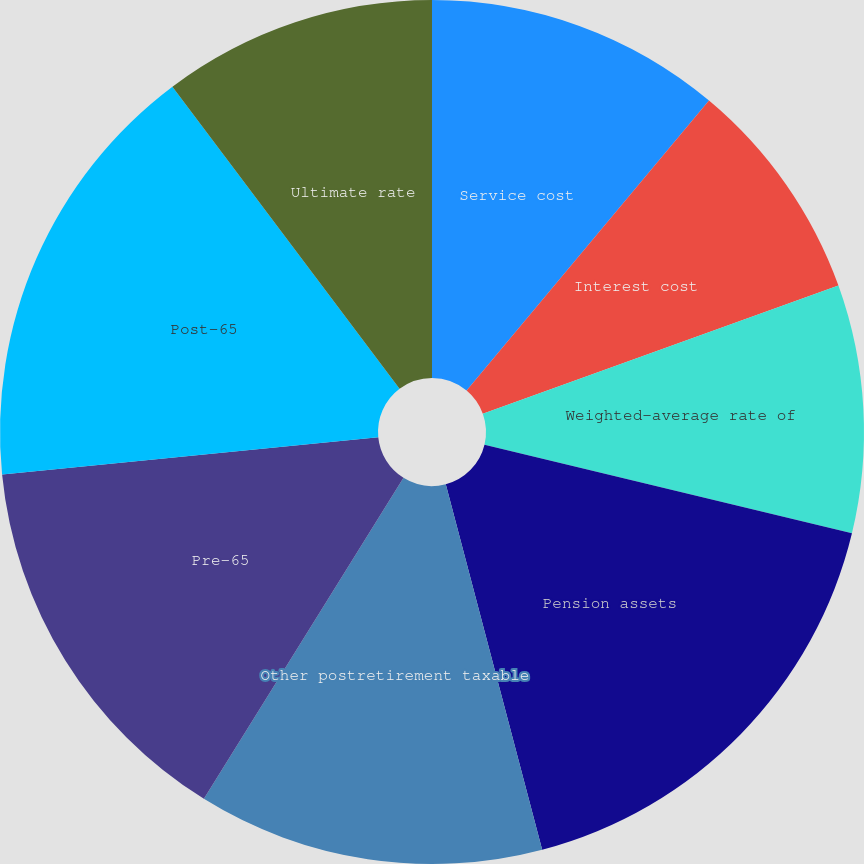<chart> <loc_0><loc_0><loc_500><loc_500><pie_chart><fcel>Service cost<fcel>Interest cost<fcel>Weighted-average rate of<fcel>Pension assets<fcel>Other postretirement taxable<fcel>Pre-65<fcel>Post-65<fcel>Ultimate rate<nl><fcel>11.08%<fcel>8.42%<fcel>9.27%<fcel>17.13%<fcel>12.96%<fcel>14.58%<fcel>16.31%<fcel>10.26%<nl></chart> 